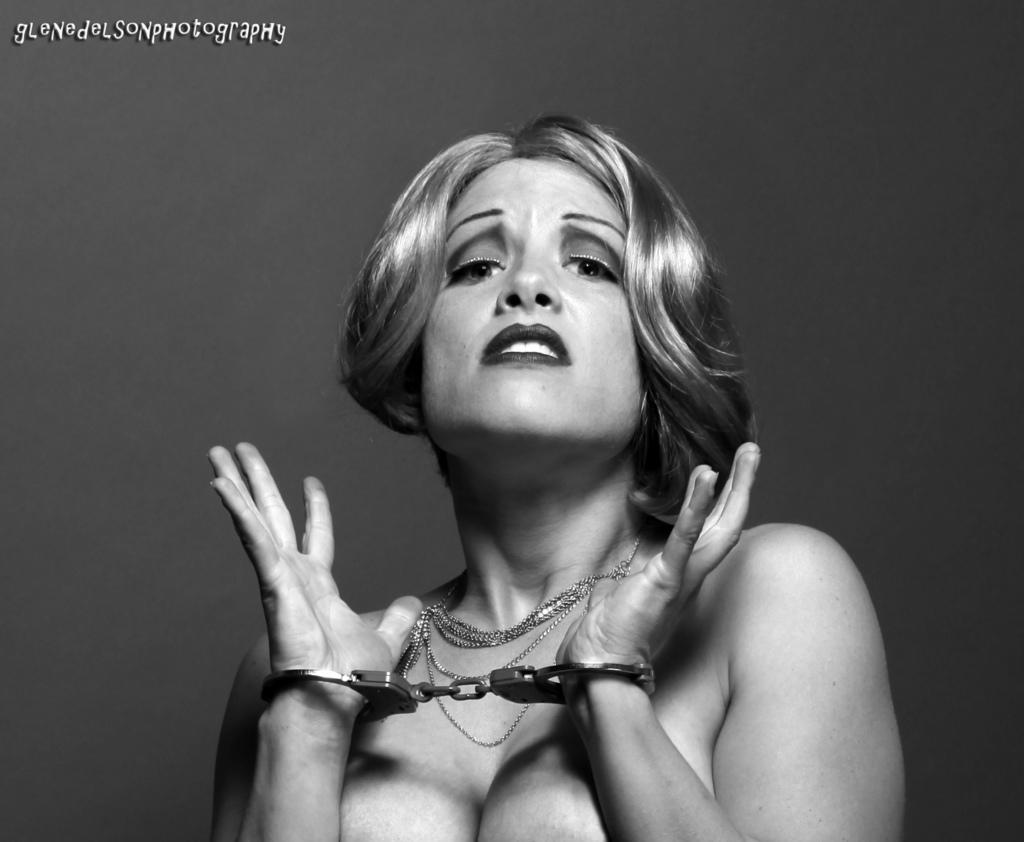Who is present in the image? There is a woman in the image. What is the woman wearing in the image? The woman is wearing handcuffs. What type of crack is the woman eating in the image? There is no crack present in the image. What is the woman's occupation as a servant in the image? There is no indication of the woman's occupation in the image. What type of oatmeal is the woman preparing in the image? There is no oatmeal present in the image. 